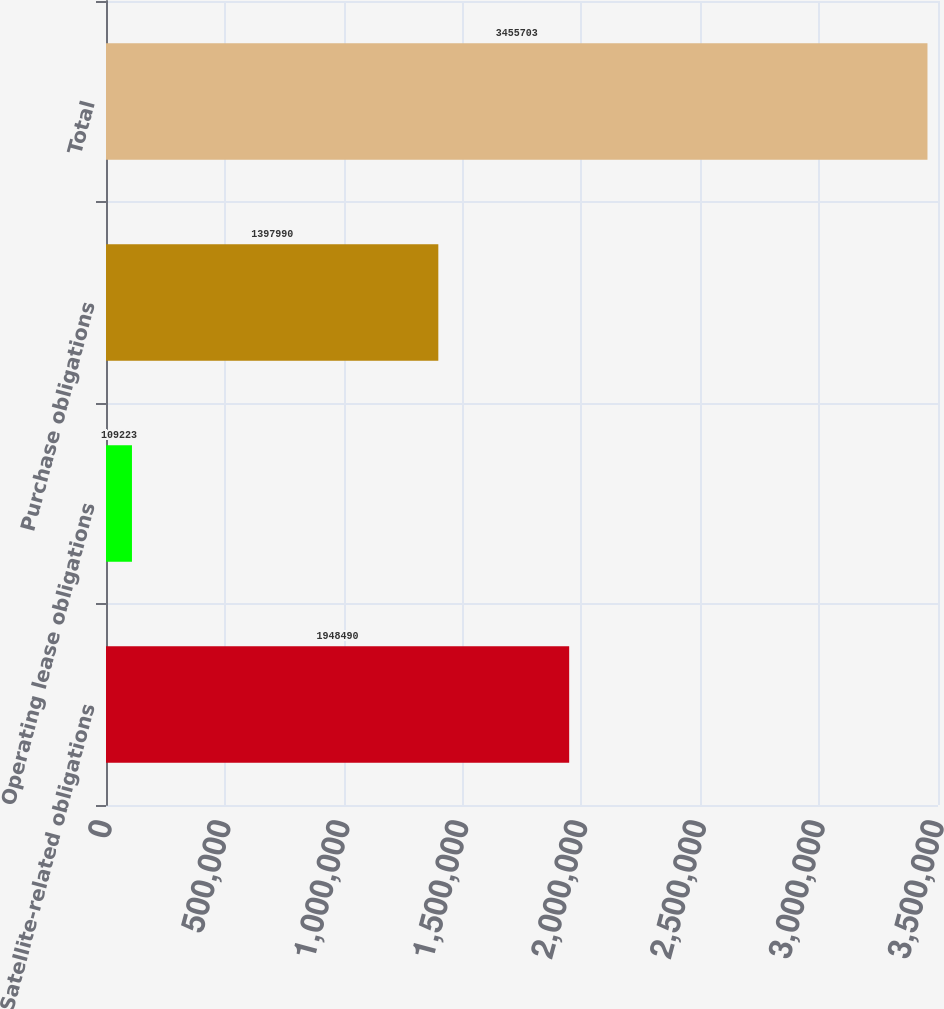Convert chart. <chart><loc_0><loc_0><loc_500><loc_500><bar_chart><fcel>Satellite-related obligations<fcel>Operating lease obligations<fcel>Purchase obligations<fcel>Total<nl><fcel>1.94849e+06<fcel>109223<fcel>1.39799e+06<fcel>3.4557e+06<nl></chart> 